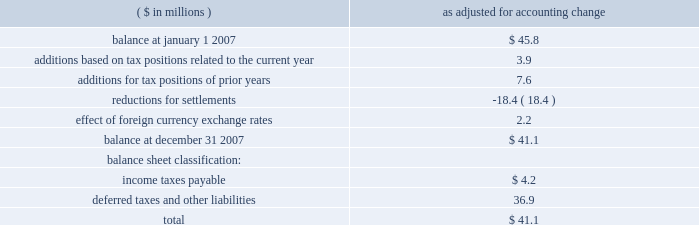Page 62 of 94 notes to consolidated financial statements ball corporation and subsidiaries 14 .
Taxes on income ( continued ) at december 31 , 2007 , ball corporation and its domestic subsidiaries had net operating loss carryforwards , expiring between 2020 and 2026 , of $ 64.6 million with a related tax benefit of $ 25.2 million .
Also at december 31 , 2007 , ball packaging europe and its subsidiaries had net operating loss carryforwards , with no expiration date , of $ 54.4 million with a related tax benefit of $ 14.6 million .
Ball packaging products canada corp .
Had a net operating loss carryforward , with no expiration date , of $ 15.8 million with a related tax benefit of $ 5.4 million .
Due to the uncertainty of ultimate realization , these european and canadian benefits have been offset by valuation allowances of $ 8.6 million and $ 5.4 million , respectively .
Upon realization , $ 5.3 million of the european valuation allowance will be recognized as a reduction in goodwill .
At december 31 , 2007 , the company has foreign tax credit carryforwards of $ 5.8 million ; however , due to the uncertainty of realization of the entire credit , a valuation allowance of $ 3.8 million has been applied to reduce the carrying value to $ 2 million .
Effective january 1 , 2007 , ball adopted fin no .
48 , 201caccounting for uncertainty in income taxes . 201d as of the date of adoption , the accrual for uncertain tax position was $ 45.8 million , and the cumulative effect of the adoption was an increase in the reserve for uncertain tax positions of $ 2.1 million .
The accrual includes an $ 11.4 million reduction in opening retained earnings and a $ 9.3 million reduction in goodwill .
A reconciliation of the unrecognized tax benefits follows : ( $ in millions ) as adjusted for accounting change .
The amount of unrecognized tax benefits at december 31 , 2007 , that , if recognized , would reduce tax expense is $ 35.9 million .
At this time there are no positions where the unrecognized tax benefit is expected to increase or decrease significantly within the next 12 months .
U.s .
Federal and state income tax returns filed for the years 2000- 2006 are open for audit , with an effective settlement of the federal returns through 2004 .
The income tax returns filed in europe for the years 2002 through 2006 are also open for audit .
The company 2019s significant filings in europe are in germany , france , the netherlands , poland , serbia and the united kingdom .
The company recognizes the accrual of interest and penalties related to unrecognized tax benefits in income tax expense .
During the year ended december 31 , 2007 , ball recognized approximately $ 2.7 million of interest expense .
The accrual for uncertain tax positions at december 31 , 2007 , includes approximately $ 5.1 million representing potential interest expense .
No penalties have been accrued .
The 2007 provision for income taxes included an $ 11.5 million accrual under fin no .
48 .
The majority of this provision was related to the effective settlement during the third quarter of 2007 with the internal revenue service for interest deductions on incurred loans from a company-owned life insurance plan .
The total accrual at december 31 , 2007 , for the effective settlement of the applicable prior years 2000-2004 under examination , and unaudited years 2005 through 2007 , was $ 18.4 million , including estimated interest .
The settlement resulted in a majority of the interest deductions being sustained with prospective application that results in no significant impact to future earnings per share or cash flows. .
What percentage of total unrecognized tax benefits as of december 31 , 2007 would affect taxes should it be recognized? 
Computations: (35.9 / 41.1)
Answer: 0.87348. 